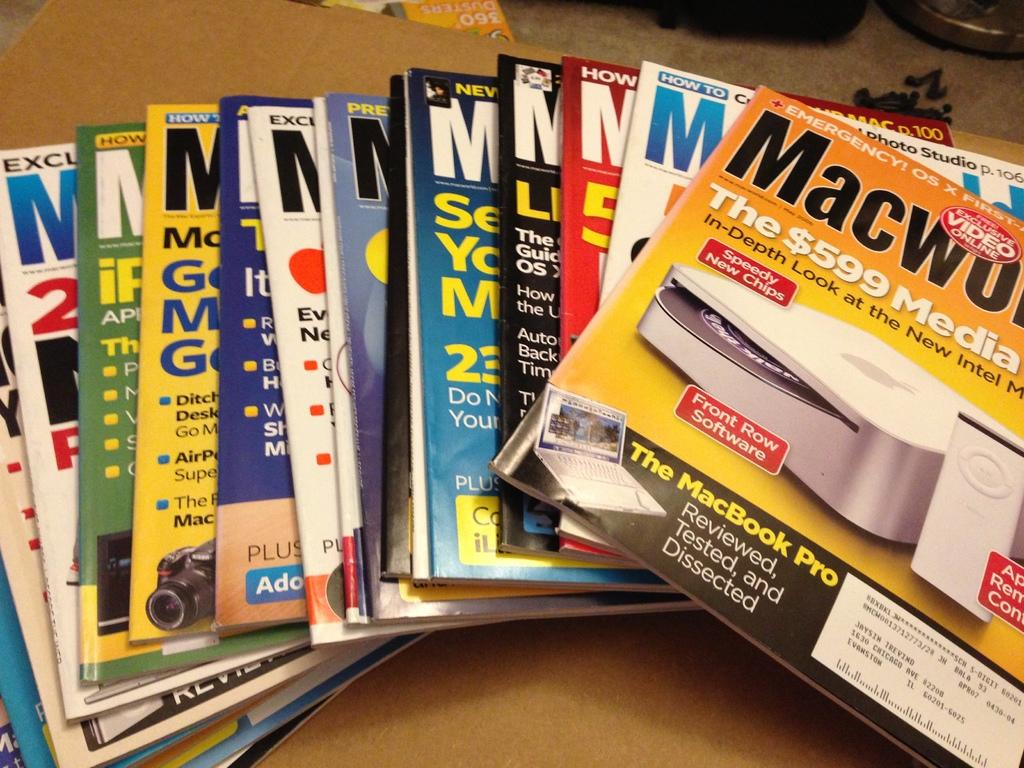<image>
Write a terse but informative summary of the picture. A magazine on top of others advertises the MacBook Pro. 